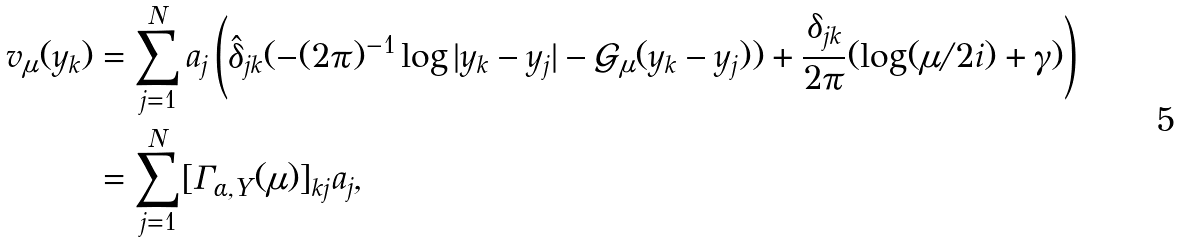<formula> <loc_0><loc_0><loc_500><loc_500>v _ { \mu } ( y _ { k } ) & = \sum _ { j = 1 } ^ { N } a _ { j } \left ( \hat { \delta } _ { j k } ( - ( 2 \pi ) ^ { - 1 } \log | y _ { k } - y _ { j } | - \mathcal { G } _ { \mu } ( y _ { k } - y _ { j } ) ) + \frac { \delta _ { j k } } { 2 \pi } ( \log ( \mu / 2 i ) + \gamma ) \right ) \\ & = \sum _ { j = 1 } ^ { N } [ \Gamma _ { \alpha , Y } ( \mu ) ] _ { k j } a _ { j } ,</formula> 